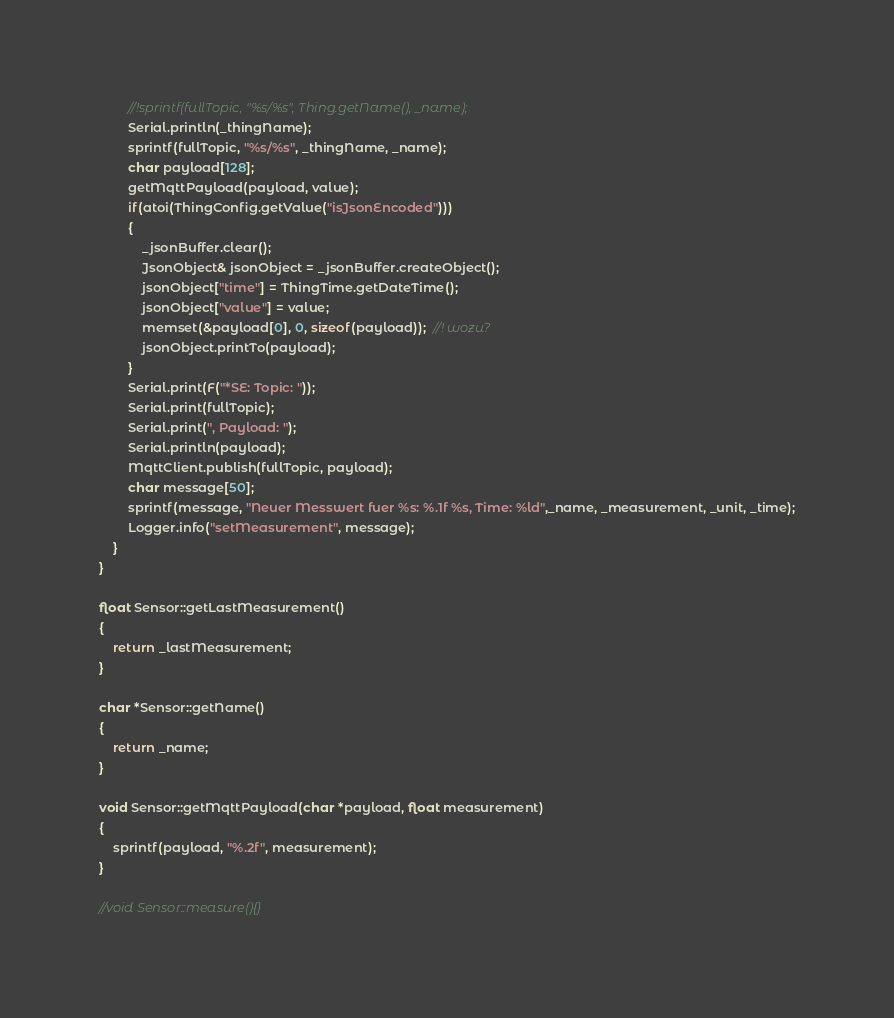Convert code to text. <code><loc_0><loc_0><loc_500><loc_500><_C++_>		//!sprintf(fullTopic, "%s/%s", Thing.getName(), _name);
		Serial.println(_thingName);
		sprintf(fullTopic, "%s/%s", _thingName, _name);
		char payload[128];
		getMqttPayload(payload, value);
		if(atoi(ThingConfig.getValue("isJsonEncoded")))
		{
			_jsonBuffer.clear();
			JsonObject& jsonObject = _jsonBuffer.createObject();
			jsonObject["time"] = ThingTime.getDateTime();
			jsonObject["value"] = value;
			memset(&payload[0], 0, sizeof(payload));  //! wozu?
			jsonObject.printTo(payload);
		}
		Serial.print(F("*SE: Topic: "));
		Serial.print(fullTopic);
		Serial.print(", Payload: ");
		Serial.println(payload);
		MqttClient.publish(fullTopic, payload);
		char message[50];
		sprintf(message, "Neuer Messwert fuer %s: %.1f %s, Time: %ld",_name, _measurement, _unit, _time);
		Logger.info("setMeasurement", message);
	}
}

float Sensor::getLastMeasurement()
{
	return _lastMeasurement;
}

char *Sensor::getName()
{
	return _name;
}

void Sensor::getMqttPayload(char *payload, float measurement)
{
	sprintf(payload, "%.2f", measurement);
}

//void Sensor::measure(){}
</code> 